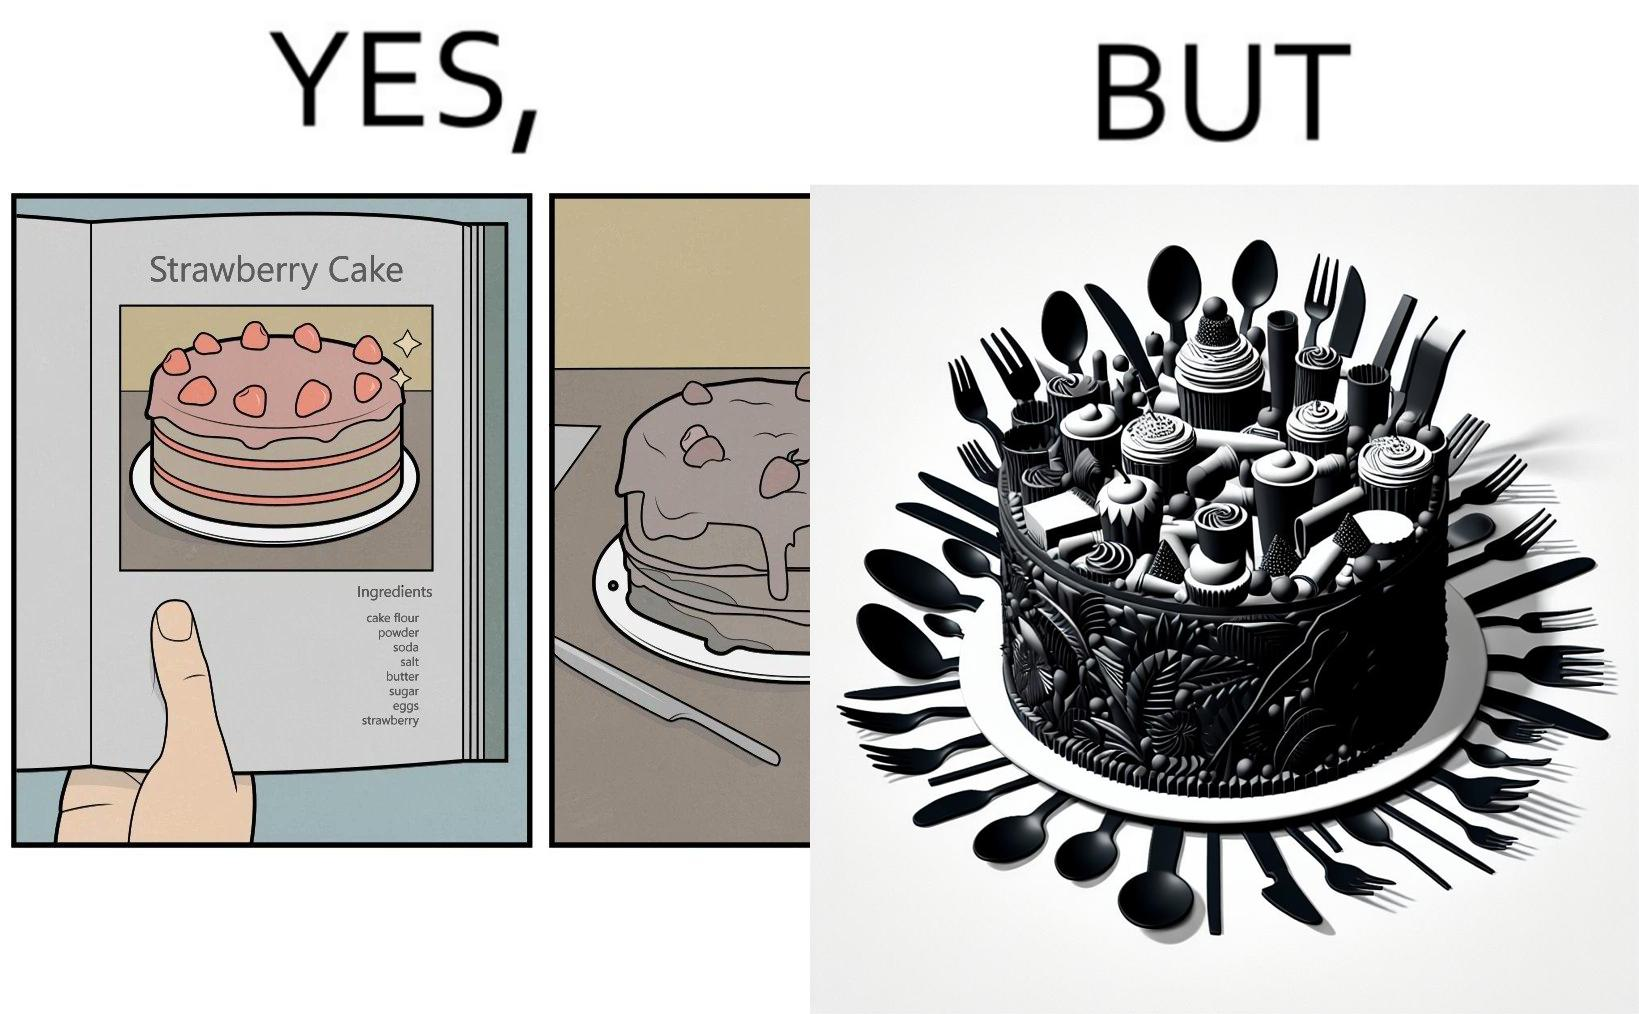What does this image depict? The image is funny, as when making a strawberry cake using  a recipe book, the outcome is not quite what is expected, and one has to wash the used utensils afterwards as well. 